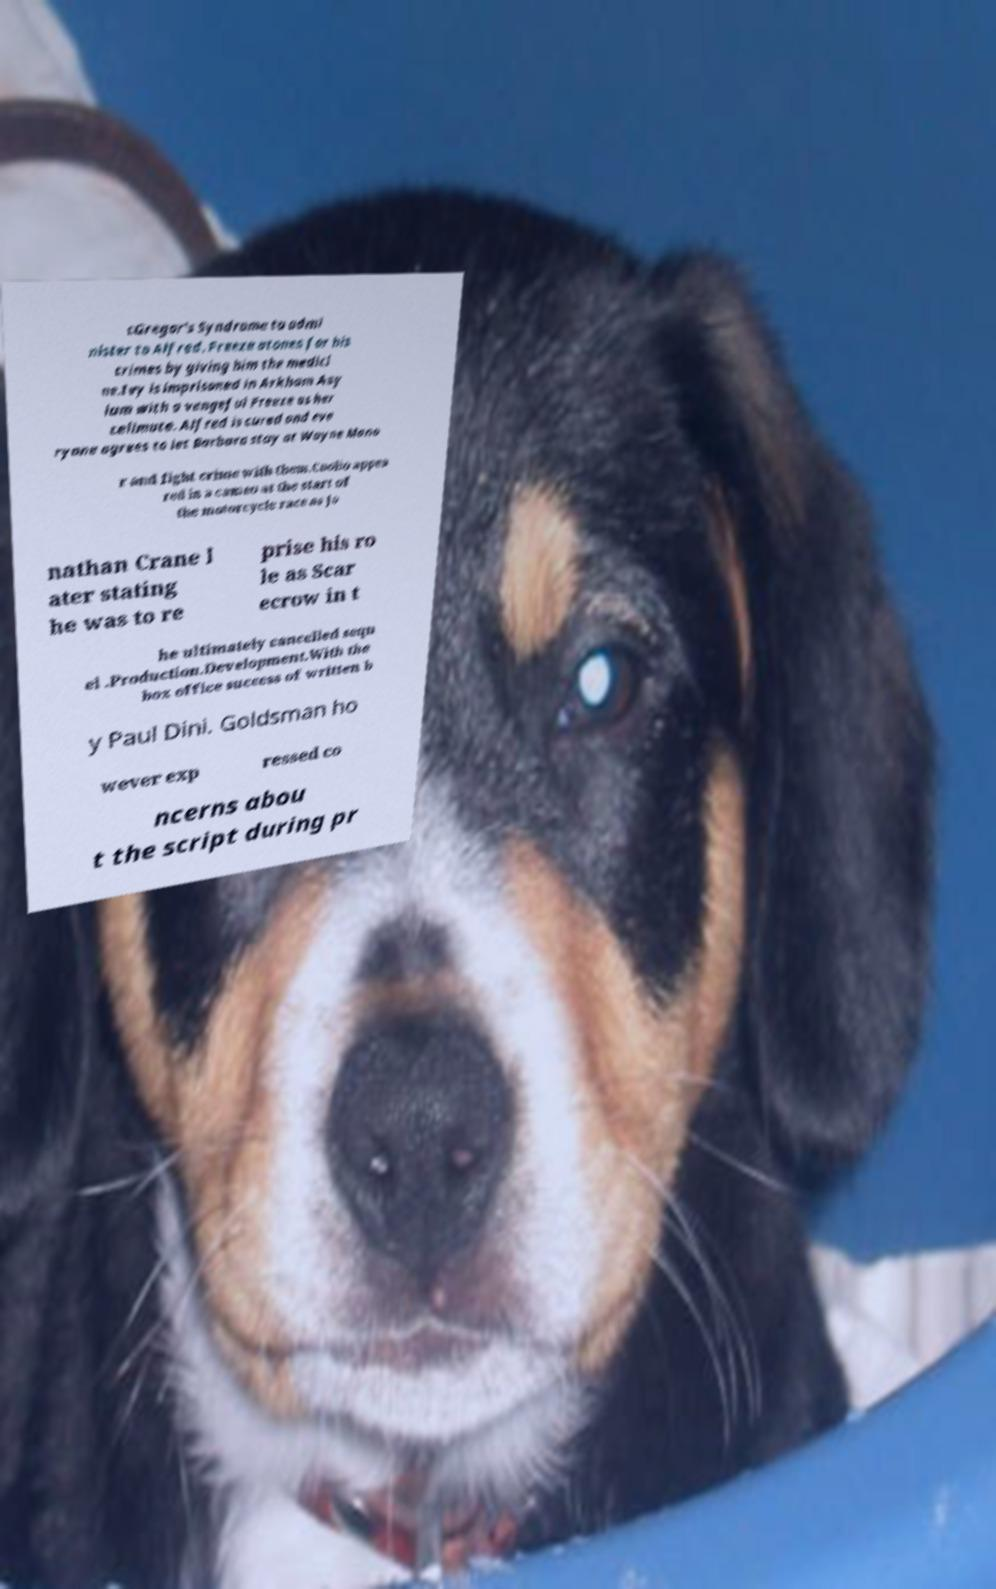I need the written content from this picture converted into text. Can you do that? cGregor's Syndrome to admi nister to Alfred. Freeze atones for his crimes by giving him the medici ne.Ivy is imprisoned in Arkham Asy lum with a vengeful Freeze as her cellmate. Alfred is cured and eve ryone agrees to let Barbara stay at Wayne Mano r and fight crime with them.Coolio appea red in a cameo at the start of the motorcycle race as Jo nathan Crane l ater stating he was to re prise his ro le as Scar ecrow in t he ultimately cancelled sequ el .Production.Development.With the box office success of written b y Paul Dini. Goldsman ho wever exp ressed co ncerns abou t the script during pr 